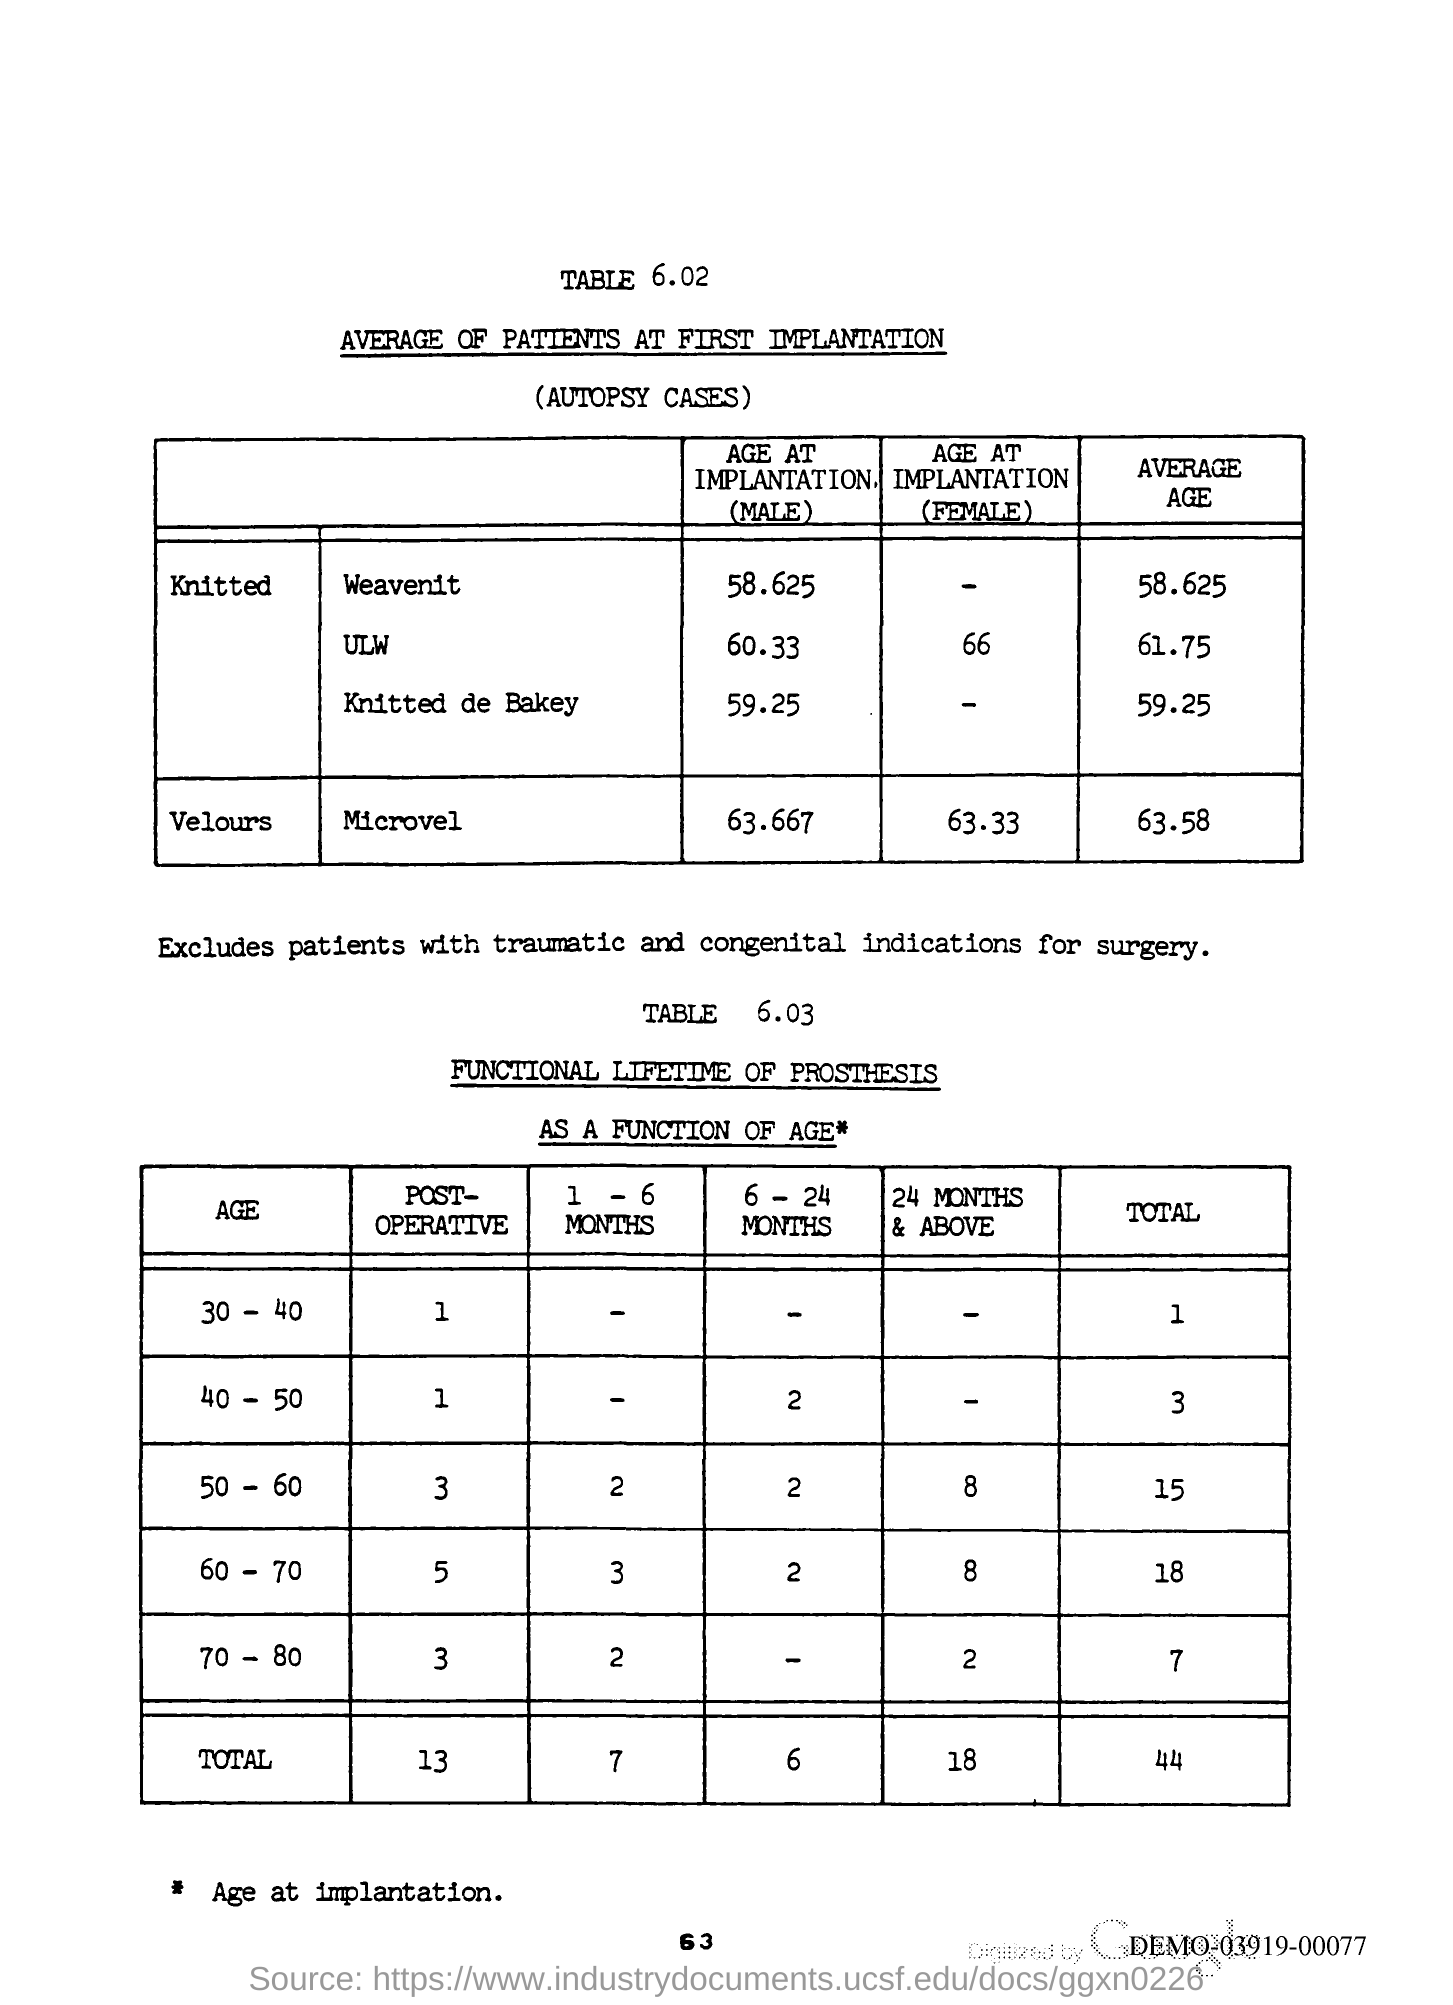Specify some key components in this picture. The page number is 63. 